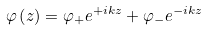<formula> <loc_0><loc_0><loc_500><loc_500>\varphi \left ( z \right ) = \varphi _ { + } e ^ { + i k z } + \varphi _ { - } e ^ { - i k z }</formula> 